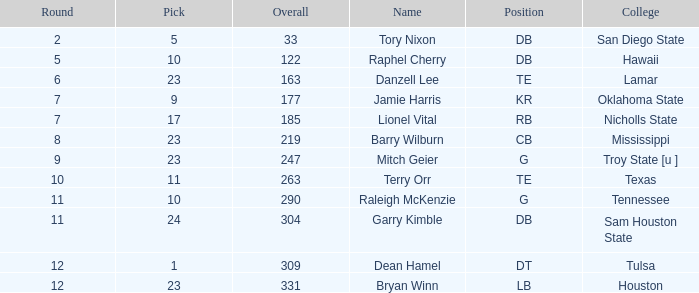What is the number of picks with an overall less than 304, a position of g, and a round less than 11? 1.0. 